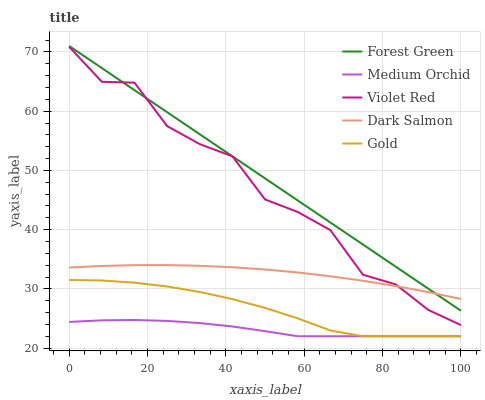Does Violet Red have the minimum area under the curve?
Answer yes or no. No. Does Violet Red have the maximum area under the curve?
Answer yes or no. No. Is Medium Orchid the smoothest?
Answer yes or no. No. Is Medium Orchid the roughest?
Answer yes or no. No. Does Violet Red have the lowest value?
Answer yes or no. No. Does Violet Red have the highest value?
Answer yes or no. No. Is Medium Orchid less than Forest Green?
Answer yes or no. Yes. Is Dark Salmon greater than Gold?
Answer yes or no. Yes. Does Medium Orchid intersect Forest Green?
Answer yes or no. No. 